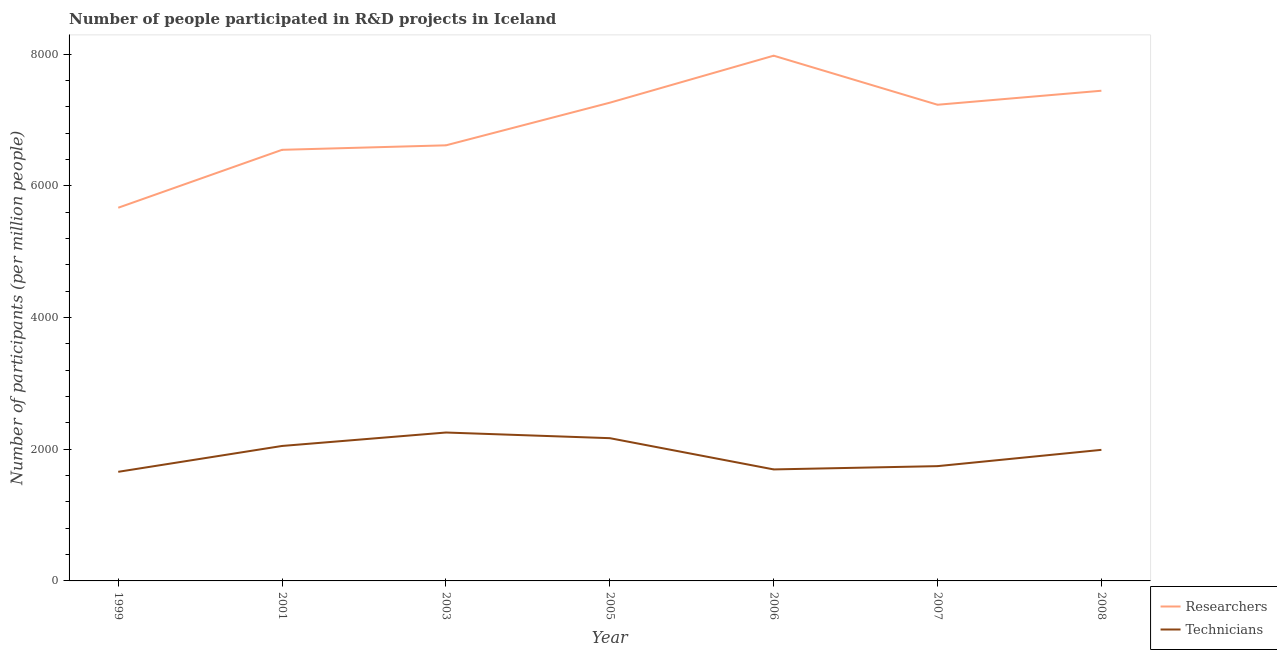Is the number of lines equal to the number of legend labels?
Offer a terse response. Yes. What is the number of technicians in 1999?
Your answer should be compact. 1656.75. Across all years, what is the maximum number of technicians?
Keep it short and to the point. 2253.45. Across all years, what is the minimum number of researchers?
Provide a succinct answer. 5666.8. In which year was the number of technicians maximum?
Keep it short and to the point. 2003. In which year was the number of researchers minimum?
Provide a succinct answer. 1999. What is the total number of researchers in the graph?
Make the answer very short. 4.87e+04. What is the difference between the number of technicians in 1999 and that in 2006?
Your answer should be very brief. -36.35. What is the difference between the number of technicians in 2005 and the number of researchers in 2001?
Provide a short and direct response. -4378.77. What is the average number of researchers per year?
Your answer should be compact. 6962.67. In the year 2006, what is the difference between the number of technicians and number of researchers?
Your answer should be very brief. -6282.51. What is the ratio of the number of researchers in 2005 to that in 2007?
Give a very brief answer. 1. Is the difference between the number of technicians in 1999 and 2006 greater than the difference between the number of researchers in 1999 and 2006?
Ensure brevity in your answer.  Yes. What is the difference between the highest and the second highest number of researchers?
Offer a very short reply. 532.3. What is the difference between the highest and the lowest number of researchers?
Your answer should be very brief. 2308.82. Is the sum of the number of technicians in 1999 and 2006 greater than the maximum number of researchers across all years?
Your answer should be very brief. No. How many years are there in the graph?
Your answer should be compact. 7. What is the difference between two consecutive major ticks on the Y-axis?
Your answer should be very brief. 2000. Are the values on the major ticks of Y-axis written in scientific E-notation?
Ensure brevity in your answer.  No. Does the graph contain any zero values?
Make the answer very short. No. Does the graph contain grids?
Provide a short and direct response. No. How many legend labels are there?
Your answer should be compact. 2. What is the title of the graph?
Provide a succinct answer. Number of people participated in R&D projects in Iceland. What is the label or title of the X-axis?
Your answer should be very brief. Year. What is the label or title of the Y-axis?
Offer a terse response. Number of participants (per million people). What is the Number of participants (per million people) in Researchers in 1999?
Offer a terse response. 5666.8. What is the Number of participants (per million people) in Technicians in 1999?
Give a very brief answer. 1656.75. What is the Number of participants (per million people) of Researchers in 2001?
Offer a terse response. 6546.33. What is the Number of participants (per million people) of Technicians in 2001?
Keep it short and to the point. 2049.52. What is the Number of participants (per million people) of Researchers in 2003?
Provide a succinct answer. 6614.36. What is the Number of participants (per million people) of Technicians in 2003?
Your answer should be very brief. 2253.45. What is the Number of participants (per million people) in Researchers in 2005?
Your response must be concise. 7261.79. What is the Number of participants (per million people) of Technicians in 2005?
Offer a very short reply. 2167.56. What is the Number of participants (per million people) of Researchers in 2006?
Provide a short and direct response. 7975.62. What is the Number of participants (per million people) in Technicians in 2006?
Your response must be concise. 1693.11. What is the Number of participants (per million people) in Researchers in 2007?
Ensure brevity in your answer.  7230.49. What is the Number of participants (per million people) in Technicians in 2007?
Your answer should be very brief. 1742.94. What is the Number of participants (per million people) of Researchers in 2008?
Provide a succinct answer. 7443.32. What is the Number of participants (per million people) in Technicians in 2008?
Your answer should be compact. 1990.23. Across all years, what is the maximum Number of participants (per million people) in Researchers?
Ensure brevity in your answer.  7975.62. Across all years, what is the maximum Number of participants (per million people) in Technicians?
Give a very brief answer. 2253.45. Across all years, what is the minimum Number of participants (per million people) in Researchers?
Make the answer very short. 5666.8. Across all years, what is the minimum Number of participants (per million people) in Technicians?
Give a very brief answer. 1656.75. What is the total Number of participants (per million people) of Researchers in the graph?
Offer a very short reply. 4.87e+04. What is the total Number of participants (per million people) of Technicians in the graph?
Offer a very short reply. 1.36e+04. What is the difference between the Number of participants (per million people) of Researchers in 1999 and that in 2001?
Provide a succinct answer. -879.53. What is the difference between the Number of participants (per million people) in Technicians in 1999 and that in 2001?
Offer a terse response. -392.77. What is the difference between the Number of participants (per million people) in Researchers in 1999 and that in 2003?
Offer a very short reply. -947.56. What is the difference between the Number of participants (per million people) in Technicians in 1999 and that in 2003?
Keep it short and to the point. -596.7. What is the difference between the Number of participants (per million people) of Researchers in 1999 and that in 2005?
Give a very brief answer. -1594.99. What is the difference between the Number of participants (per million people) of Technicians in 1999 and that in 2005?
Ensure brevity in your answer.  -510.81. What is the difference between the Number of participants (per million people) in Researchers in 1999 and that in 2006?
Give a very brief answer. -2308.82. What is the difference between the Number of participants (per million people) of Technicians in 1999 and that in 2006?
Offer a very short reply. -36.35. What is the difference between the Number of participants (per million people) in Researchers in 1999 and that in 2007?
Your answer should be very brief. -1563.69. What is the difference between the Number of participants (per million people) of Technicians in 1999 and that in 2007?
Give a very brief answer. -86.19. What is the difference between the Number of participants (per million people) in Researchers in 1999 and that in 2008?
Ensure brevity in your answer.  -1776.52. What is the difference between the Number of participants (per million people) in Technicians in 1999 and that in 2008?
Ensure brevity in your answer.  -333.48. What is the difference between the Number of participants (per million people) of Researchers in 2001 and that in 2003?
Your response must be concise. -68.03. What is the difference between the Number of participants (per million people) of Technicians in 2001 and that in 2003?
Offer a terse response. -203.93. What is the difference between the Number of participants (per million people) in Researchers in 2001 and that in 2005?
Offer a terse response. -715.46. What is the difference between the Number of participants (per million people) in Technicians in 2001 and that in 2005?
Provide a succinct answer. -118.04. What is the difference between the Number of participants (per million people) in Researchers in 2001 and that in 2006?
Make the answer very short. -1429.29. What is the difference between the Number of participants (per million people) of Technicians in 2001 and that in 2006?
Provide a short and direct response. 356.41. What is the difference between the Number of participants (per million people) in Researchers in 2001 and that in 2007?
Your answer should be compact. -684.16. What is the difference between the Number of participants (per million people) in Technicians in 2001 and that in 2007?
Provide a short and direct response. 306.58. What is the difference between the Number of participants (per million people) in Researchers in 2001 and that in 2008?
Give a very brief answer. -896.99. What is the difference between the Number of participants (per million people) of Technicians in 2001 and that in 2008?
Provide a short and direct response. 59.29. What is the difference between the Number of participants (per million people) in Researchers in 2003 and that in 2005?
Offer a terse response. -647.43. What is the difference between the Number of participants (per million people) of Technicians in 2003 and that in 2005?
Offer a very short reply. 85.89. What is the difference between the Number of participants (per million people) of Researchers in 2003 and that in 2006?
Offer a very short reply. -1361.26. What is the difference between the Number of participants (per million people) in Technicians in 2003 and that in 2006?
Your response must be concise. 560.34. What is the difference between the Number of participants (per million people) in Researchers in 2003 and that in 2007?
Make the answer very short. -616.13. What is the difference between the Number of participants (per million people) of Technicians in 2003 and that in 2007?
Offer a very short reply. 510.51. What is the difference between the Number of participants (per million people) in Researchers in 2003 and that in 2008?
Your answer should be compact. -828.96. What is the difference between the Number of participants (per million people) in Technicians in 2003 and that in 2008?
Provide a succinct answer. 263.22. What is the difference between the Number of participants (per million people) in Researchers in 2005 and that in 2006?
Your answer should be compact. -713.83. What is the difference between the Number of participants (per million people) of Technicians in 2005 and that in 2006?
Make the answer very short. 474.45. What is the difference between the Number of participants (per million people) of Researchers in 2005 and that in 2007?
Your response must be concise. 31.3. What is the difference between the Number of participants (per million people) of Technicians in 2005 and that in 2007?
Offer a terse response. 424.61. What is the difference between the Number of participants (per million people) of Researchers in 2005 and that in 2008?
Give a very brief answer. -181.53. What is the difference between the Number of participants (per million people) of Technicians in 2005 and that in 2008?
Your response must be concise. 177.33. What is the difference between the Number of participants (per million people) in Researchers in 2006 and that in 2007?
Your answer should be very brief. 745.13. What is the difference between the Number of participants (per million people) of Technicians in 2006 and that in 2007?
Ensure brevity in your answer.  -49.84. What is the difference between the Number of participants (per million people) of Researchers in 2006 and that in 2008?
Keep it short and to the point. 532.3. What is the difference between the Number of participants (per million people) of Technicians in 2006 and that in 2008?
Ensure brevity in your answer.  -297.12. What is the difference between the Number of participants (per million people) of Researchers in 2007 and that in 2008?
Your answer should be compact. -212.83. What is the difference between the Number of participants (per million people) of Technicians in 2007 and that in 2008?
Your response must be concise. -247.28. What is the difference between the Number of participants (per million people) in Researchers in 1999 and the Number of participants (per million people) in Technicians in 2001?
Your answer should be compact. 3617.28. What is the difference between the Number of participants (per million people) of Researchers in 1999 and the Number of participants (per million people) of Technicians in 2003?
Your answer should be very brief. 3413.35. What is the difference between the Number of participants (per million people) of Researchers in 1999 and the Number of participants (per million people) of Technicians in 2005?
Keep it short and to the point. 3499.24. What is the difference between the Number of participants (per million people) in Researchers in 1999 and the Number of participants (per million people) in Technicians in 2006?
Keep it short and to the point. 3973.69. What is the difference between the Number of participants (per million people) of Researchers in 1999 and the Number of participants (per million people) of Technicians in 2007?
Your answer should be compact. 3923.85. What is the difference between the Number of participants (per million people) of Researchers in 1999 and the Number of participants (per million people) of Technicians in 2008?
Provide a short and direct response. 3676.57. What is the difference between the Number of participants (per million people) of Researchers in 2001 and the Number of participants (per million people) of Technicians in 2003?
Provide a succinct answer. 4292.88. What is the difference between the Number of participants (per million people) of Researchers in 2001 and the Number of participants (per million people) of Technicians in 2005?
Provide a succinct answer. 4378.77. What is the difference between the Number of participants (per million people) in Researchers in 2001 and the Number of participants (per million people) in Technicians in 2006?
Offer a terse response. 4853.22. What is the difference between the Number of participants (per million people) in Researchers in 2001 and the Number of participants (per million people) in Technicians in 2007?
Keep it short and to the point. 4803.39. What is the difference between the Number of participants (per million people) in Researchers in 2001 and the Number of participants (per million people) in Technicians in 2008?
Provide a succinct answer. 4556.1. What is the difference between the Number of participants (per million people) of Researchers in 2003 and the Number of participants (per million people) of Technicians in 2005?
Make the answer very short. 4446.8. What is the difference between the Number of participants (per million people) in Researchers in 2003 and the Number of participants (per million people) in Technicians in 2006?
Offer a very short reply. 4921.25. What is the difference between the Number of participants (per million people) of Researchers in 2003 and the Number of participants (per million people) of Technicians in 2007?
Give a very brief answer. 4871.42. What is the difference between the Number of participants (per million people) in Researchers in 2003 and the Number of participants (per million people) in Technicians in 2008?
Provide a short and direct response. 4624.13. What is the difference between the Number of participants (per million people) in Researchers in 2005 and the Number of participants (per million people) in Technicians in 2006?
Provide a succinct answer. 5568.68. What is the difference between the Number of participants (per million people) of Researchers in 2005 and the Number of participants (per million people) of Technicians in 2007?
Offer a terse response. 5518.85. What is the difference between the Number of participants (per million people) of Researchers in 2005 and the Number of participants (per million people) of Technicians in 2008?
Your response must be concise. 5271.56. What is the difference between the Number of participants (per million people) of Researchers in 2006 and the Number of participants (per million people) of Technicians in 2007?
Give a very brief answer. 6232.68. What is the difference between the Number of participants (per million people) in Researchers in 2006 and the Number of participants (per million people) in Technicians in 2008?
Your answer should be compact. 5985.39. What is the difference between the Number of participants (per million people) of Researchers in 2007 and the Number of participants (per million people) of Technicians in 2008?
Provide a succinct answer. 5240.26. What is the average Number of participants (per million people) in Researchers per year?
Make the answer very short. 6962.67. What is the average Number of participants (per million people) of Technicians per year?
Keep it short and to the point. 1936.22. In the year 1999, what is the difference between the Number of participants (per million people) of Researchers and Number of participants (per million people) of Technicians?
Offer a terse response. 4010.04. In the year 2001, what is the difference between the Number of participants (per million people) in Researchers and Number of participants (per million people) in Technicians?
Offer a very short reply. 4496.81. In the year 2003, what is the difference between the Number of participants (per million people) of Researchers and Number of participants (per million people) of Technicians?
Ensure brevity in your answer.  4360.91. In the year 2005, what is the difference between the Number of participants (per million people) in Researchers and Number of participants (per million people) in Technicians?
Provide a succinct answer. 5094.23. In the year 2006, what is the difference between the Number of participants (per million people) in Researchers and Number of participants (per million people) in Technicians?
Give a very brief answer. 6282.51. In the year 2007, what is the difference between the Number of participants (per million people) in Researchers and Number of participants (per million people) in Technicians?
Make the answer very short. 5487.55. In the year 2008, what is the difference between the Number of participants (per million people) of Researchers and Number of participants (per million people) of Technicians?
Keep it short and to the point. 5453.09. What is the ratio of the Number of participants (per million people) in Researchers in 1999 to that in 2001?
Give a very brief answer. 0.87. What is the ratio of the Number of participants (per million people) of Technicians in 1999 to that in 2001?
Provide a short and direct response. 0.81. What is the ratio of the Number of participants (per million people) in Researchers in 1999 to that in 2003?
Keep it short and to the point. 0.86. What is the ratio of the Number of participants (per million people) in Technicians in 1999 to that in 2003?
Give a very brief answer. 0.74. What is the ratio of the Number of participants (per million people) of Researchers in 1999 to that in 2005?
Your answer should be very brief. 0.78. What is the ratio of the Number of participants (per million people) in Technicians in 1999 to that in 2005?
Offer a very short reply. 0.76. What is the ratio of the Number of participants (per million people) in Researchers in 1999 to that in 2006?
Your answer should be compact. 0.71. What is the ratio of the Number of participants (per million people) in Technicians in 1999 to that in 2006?
Offer a very short reply. 0.98. What is the ratio of the Number of participants (per million people) of Researchers in 1999 to that in 2007?
Your answer should be very brief. 0.78. What is the ratio of the Number of participants (per million people) in Technicians in 1999 to that in 2007?
Your answer should be very brief. 0.95. What is the ratio of the Number of participants (per million people) of Researchers in 1999 to that in 2008?
Your response must be concise. 0.76. What is the ratio of the Number of participants (per million people) of Technicians in 1999 to that in 2008?
Give a very brief answer. 0.83. What is the ratio of the Number of participants (per million people) in Researchers in 2001 to that in 2003?
Your response must be concise. 0.99. What is the ratio of the Number of participants (per million people) of Technicians in 2001 to that in 2003?
Keep it short and to the point. 0.91. What is the ratio of the Number of participants (per million people) of Researchers in 2001 to that in 2005?
Keep it short and to the point. 0.9. What is the ratio of the Number of participants (per million people) of Technicians in 2001 to that in 2005?
Your response must be concise. 0.95. What is the ratio of the Number of participants (per million people) of Researchers in 2001 to that in 2006?
Keep it short and to the point. 0.82. What is the ratio of the Number of participants (per million people) of Technicians in 2001 to that in 2006?
Make the answer very short. 1.21. What is the ratio of the Number of participants (per million people) of Researchers in 2001 to that in 2007?
Your answer should be very brief. 0.91. What is the ratio of the Number of participants (per million people) of Technicians in 2001 to that in 2007?
Offer a very short reply. 1.18. What is the ratio of the Number of participants (per million people) of Researchers in 2001 to that in 2008?
Provide a short and direct response. 0.88. What is the ratio of the Number of participants (per million people) of Technicians in 2001 to that in 2008?
Your response must be concise. 1.03. What is the ratio of the Number of participants (per million people) of Researchers in 2003 to that in 2005?
Your answer should be very brief. 0.91. What is the ratio of the Number of participants (per million people) in Technicians in 2003 to that in 2005?
Offer a terse response. 1.04. What is the ratio of the Number of participants (per million people) of Researchers in 2003 to that in 2006?
Give a very brief answer. 0.83. What is the ratio of the Number of participants (per million people) of Technicians in 2003 to that in 2006?
Your answer should be compact. 1.33. What is the ratio of the Number of participants (per million people) in Researchers in 2003 to that in 2007?
Offer a very short reply. 0.91. What is the ratio of the Number of participants (per million people) of Technicians in 2003 to that in 2007?
Offer a very short reply. 1.29. What is the ratio of the Number of participants (per million people) of Researchers in 2003 to that in 2008?
Offer a terse response. 0.89. What is the ratio of the Number of participants (per million people) of Technicians in 2003 to that in 2008?
Provide a short and direct response. 1.13. What is the ratio of the Number of participants (per million people) of Researchers in 2005 to that in 2006?
Give a very brief answer. 0.91. What is the ratio of the Number of participants (per million people) of Technicians in 2005 to that in 2006?
Make the answer very short. 1.28. What is the ratio of the Number of participants (per million people) of Researchers in 2005 to that in 2007?
Your answer should be very brief. 1. What is the ratio of the Number of participants (per million people) in Technicians in 2005 to that in 2007?
Offer a very short reply. 1.24. What is the ratio of the Number of participants (per million people) of Researchers in 2005 to that in 2008?
Keep it short and to the point. 0.98. What is the ratio of the Number of participants (per million people) of Technicians in 2005 to that in 2008?
Make the answer very short. 1.09. What is the ratio of the Number of participants (per million people) of Researchers in 2006 to that in 2007?
Provide a succinct answer. 1.1. What is the ratio of the Number of participants (per million people) of Technicians in 2006 to that in 2007?
Give a very brief answer. 0.97. What is the ratio of the Number of participants (per million people) of Researchers in 2006 to that in 2008?
Keep it short and to the point. 1.07. What is the ratio of the Number of participants (per million people) in Technicians in 2006 to that in 2008?
Your answer should be very brief. 0.85. What is the ratio of the Number of participants (per million people) in Researchers in 2007 to that in 2008?
Provide a short and direct response. 0.97. What is the ratio of the Number of participants (per million people) of Technicians in 2007 to that in 2008?
Your answer should be compact. 0.88. What is the difference between the highest and the second highest Number of participants (per million people) in Researchers?
Keep it short and to the point. 532.3. What is the difference between the highest and the second highest Number of participants (per million people) of Technicians?
Your response must be concise. 85.89. What is the difference between the highest and the lowest Number of participants (per million people) of Researchers?
Offer a terse response. 2308.82. What is the difference between the highest and the lowest Number of participants (per million people) of Technicians?
Your response must be concise. 596.7. 